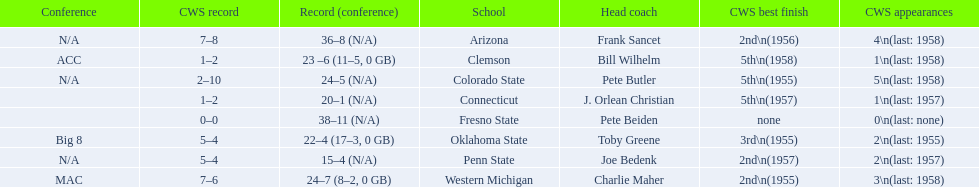What are all of the schools? Arizona, Clemson, Colorado State, Connecticut, Fresno State, Oklahoma State, Penn State, Western Michigan. Which team had fewer than 20 wins? Penn State. 